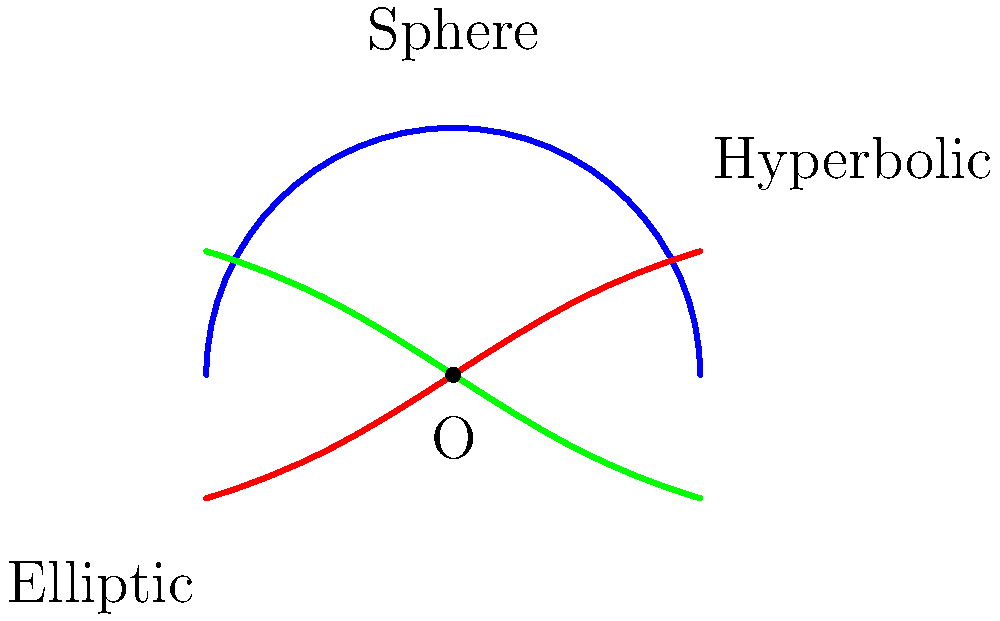Consider three non-Euclidean surfaces resembling popular tourist landmarks: a spherical dome ($S$), a hyperbolic art installation ($H$), and an elliptic-shaped observation deck ($E$). All three surfaces pass through a common point $O$. Based on the curvature of these surfaces near point $O$, which one has the greatest absolute curvature? To compare the curvature of these non-Euclidean surfaces, we need to analyze their shape near the common point $O$:

1. Spherical surface ($S$):
   - Has a constant positive curvature.
   - Its curvature is $K = \frac{1}{R^2}$, where $R$ is the radius of the sphere.

2. Hyperbolic surface ($H$):
   - Has a constant negative curvature.
   - Its curvature is $K = -\frac{1}{a^2}$, where $a$ is a constant related to the surface's shape.

3. Elliptic surface ($E$):
   - Has a varying positive curvature.
   - Its curvature depends on the position and the shape of the ellipse.

Near point $O$:
- The spherical surface ($S$) maintains its constant curvature.
- The hyperbolic surface ($H$) curves away from the tangent plane more rapidly than the sphere.
- The elliptic surface ($E$) curves less than the sphere at this point.

Comparing absolute curvatures:
- $|K_H| > |K_S| > |K_E|$

Therefore, the hyperbolic surface ($H$) has the greatest absolute curvature near point $O$.
Answer: Hyperbolic surface ($H$) 